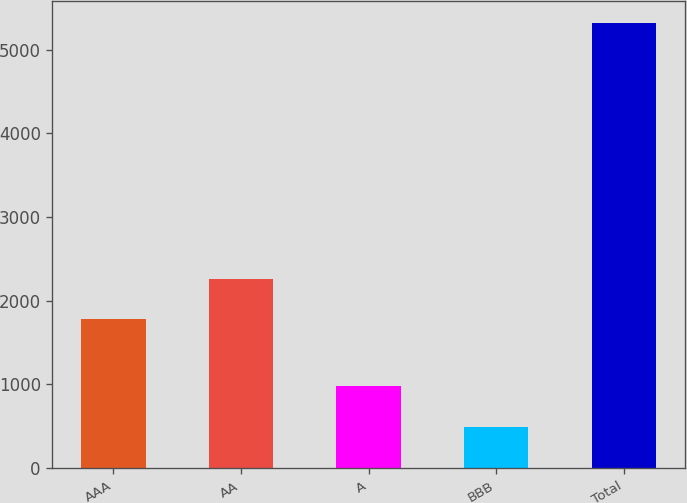Convert chart. <chart><loc_0><loc_0><loc_500><loc_500><bar_chart><fcel>AAA<fcel>AA<fcel>A<fcel>BBB<fcel>Total<nl><fcel>1780<fcel>2262.4<fcel>978.4<fcel>496<fcel>5320<nl></chart> 